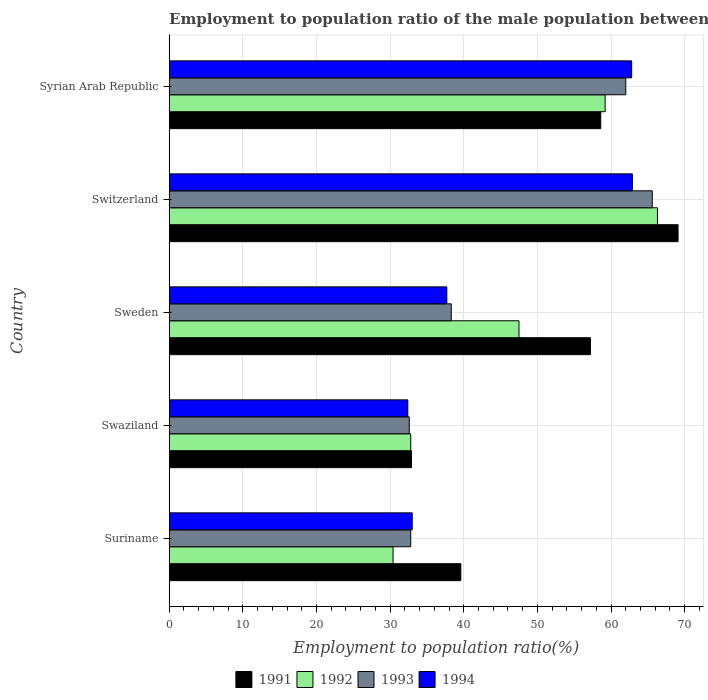How many different coloured bars are there?
Provide a short and direct response. 4. Are the number of bars on each tick of the Y-axis equal?
Make the answer very short. Yes. How many bars are there on the 1st tick from the top?
Your answer should be very brief. 4. How many bars are there on the 3rd tick from the bottom?
Ensure brevity in your answer.  4. What is the label of the 5th group of bars from the top?
Provide a succinct answer. Suriname. In how many cases, is the number of bars for a given country not equal to the number of legend labels?
Your response must be concise. 0. What is the employment to population ratio in 1991 in Suriname?
Your response must be concise. 39.6. Across all countries, what is the maximum employment to population ratio in 1993?
Offer a terse response. 65.6. Across all countries, what is the minimum employment to population ratio in 1991?
Offer a terse response. 32.9. In which country was the employment to population ratio in 1992 maximum?
Offer a terse response. Switzerland. In which country was the employment to population ratio in 1991 minimum?
Provide a succinct answer. Swaziland. What is the total employment to population ratio in 1993 in the graph?
Offer a very short reply. 231.3. What is the difference between the employment to population ratio in 1992 in Switzerland and that in Syrian Arab Republic?
Provide a short and direct response. 7.1. What is the average employment to population ratio in 1993 per country?
Make the answer very short. 46.26. What is the difference between the employment to population ratio in 1992 and employment to population ratio in 1994 in Syrian Arab Republic?
Ensure brevity in your answer.  -3.6. What is the ratio of the employment to population ratio in 1992 in Switzerland to that in Syrian Arab Republic?
Your response must be concise. 1.12. Is the difference between the employment to population ratio in 1992 in Swaziland and Syrian Arab Republic greater than the difference between the employment to population ratio in 1994 in Swaziland and Syrian Arab Republic?
Give a very brief answer. Yes. What is the difference between the highest and the second highest employment to population ratio in 1994?
Offer a very short reply. 0.1. What is the difference between the highest and the lowest employment to population ratio in 1991?
Offer a terse response. 36.2. In how many countries, is the employment to population ratio in 1992 greater than the average employment to population ratio in 1992 taken over all countries?
Your answer should be compact. 3. Is the sum of the employment to population ratio in 1992 in Suriname and Switzerland greater than the maximum employment to population ratio in 1994 across all countries?
Ensure brevity in your answer.  Yes. Is it the case that in every country, the sum of the employment to population ratio in 1992 and employment to population ratio in 1991 is greater than the sum of employment to population ratio in 1993 and employment to population ratio in 1994?
Provide a succinct answer. No. How many bars are there?
Make the answer very short. 20. Does the graph contain grids?
Make the answer very short. Yes. How are the legend labels stacked?
Offer a very short reply. Horizontal. What is the title of the graph?
Keep it short and to the point. Employment to population ratio of the male population between the ages 0 to 14. What is the label or title of the X-axis?
Give a very brief answer. Employment to population ratio(%). What is the label or title of the Y-axis?
Provide a short and direct response. Country. What is the Employment to population ratio(%) in 1991 in Suriname?
Offer a terse response. 39.6. What is the Employment to population ratio(%) of 1992 in Suriname?
Keep it short and to the point. 30.4. What is the Employment to population ratio(%) in 1993 in Suriname?
Provide a succinct answer. 32.8. What is the Employment to population ratio(%) of 1991 in Swaziland?
Your response must be concise. 32.9. What is the Employment to population ratio(%) of 1992 in Swaziland?
Give a very brief answer. 32.8. What is the Employment to population ratio(%) of 1993 in Swaziland?
Your answer should be compact. 32.6. What is the Employment to population ratio(%) in 1994 in Swaziland?
Make the answer very short. 32.4. What is the Employment to population ratio(%) of 1991 in Sweden?
Your answer should be very brief. 57.2. What is the Employment to population ratio(%) of 1992 in Sweden?
Offer a terse response. 47.5. What is the Employment to population ratio(%) of 1993 in Sweden?
Keep it short and to the point. 38.3. What is the Employment to population ratio(%) in 1994 in Sweden?
Offer a terse response. 37.7. What is the Employment to population ratio(%) in 1991 in Switzerland?
Ensure brevity in your answer.  69.1. What is the Employment to population ratio(%) of 1992 in Switzerland?
Your answer should be very brief. 66.3. What is the Employment to population ratio(%) of 1993 in Switzerland?
Offer a terse response. 65.6. What is the Employment to population ratio(%) of 1994 in Switzerland?
Make the answer very short. 62.9. What is the Employment to population ratio(%) in 1991 in Syrian Arab Republic?
Provide a succinct answer. 58.6. What is the Employment to population ratio(%) of 1992 in Syrian Arab Republic?
Provide a short and direct response. 59.2. What is the Employment to population ratio(%) of 1993 in Syrian Arab Republic?
Ensure brevity in your answer.  62. What is the Employment to population ratio(%) in 1994 in Syrian Arab Republic?
Keep it short and to the point. 62.8. Across all countries, what is the maximum Employment to population ratio(%) of 1991?
Give a very brief answer. 69.1. Across all countries, what is the maximum Employment to population ratio(%) of 1992?
Your answer should be very brief. 66.3. Across all countries, what is the maximum Employment to population ratio(%) of 1993?
Your response must be concise. 65.6. Across all countries, what is the maximum Employment to population ratio(%) of 1994?
Keep it short and to the point. 62.9. Across all countries, what is the minimum Employment to population ratio(%) of 1991?
Offer a very short reply. 32.9. Across all countries, what is the minimum Employment to population ratio(%) in 1992?
Your answer should be compact. 30.4. Across all countries, what is the minimum Employment to population ratio(%) in 1993?
Keep it short and to the point. 32.6. Across all countries, what is the minimum Employment to population ratio(%) of 1994?
Offer a terse response. 32.4. What is the total Employment to population ratio(%) of 1991 in the graph?
Ensure brevity in your answer.  257.4. What is the total Employment to population ratio(%) of 1992 in the graph?
Provide a short and direct response. 236.2. What is the total Employment to population ratio(%) of 1993 in the graph?
Give a very brief answer. 231.3. What is the total Employment to population ratio(%) in 1994 in the graph?
Ensure brevity in your answer.  228.8. What is the difference between the Employment to population ratio(%) of 1991 in Suriname and that in Swaziland?
Your answer should be very brief. 6.7. What is the difference between the Employment to population ratio(%) in 1994 in Suriname and that in Swaziland?
Offer a terse response. 0.6. What is the difference between the Employment to population ratio(%) in 1991 in Suriname and that in Sweden?
Ensure brevity in your answer.  -17.6. What is the difference between the Employment to population ratio(%) in 1992 in Suriname and that in Sweden?
Ensure brevity in your answer.  -17.1. What is the difference between the Employment to population ratio(%) of 1993 in Suriname and that in Sweden?
Make the answer very short. -5.5. What is the difference between the Employment to population ratio(%) in 1994 in Suriname and that in Sweden?
Provide a succinct answer. -4.7. What is the difference between the Employment to population ratio(%) of 1991 in Suriname and that in Switzerland?
Give a very brief answer. -29.5. What is the difference between the Employment to population ratio(%) of 1992 in Suriname and that in Switzerland?
Provide a succinct answer. -35.9. What is the difference between the Employment to population ratio(%) in 1993 in Suriname and that in Switzerland?
Make the answer very short. -32.8. What is the difference between the Employment to population ratio(%) in 1994 in Suriname and that in Switzerland?
Provide a short and direct response. -29.9. What is the difference between the Employment to population ratio(%) of 1992 in Suriname and that in Syrian Arab Republic?
Your answer should be compact. -28.8. What is the difference between the Employment to population ratio(%) in 1993 in Suriname and that in Syrian Arab Republic?
Keep it short and to the point. -29.2. What is the difference between the Employment to population ratio(%) of 1994 in Suriname and that in Syrian Arab Republic?
Your answer should be compact. -29.8. What is the difference between the Employment to population ratio(%) in 1991 in Swaziland and that in Sweden?
Make the answer very short. -24.3. What is the difference between the Employment to population ratio(%) of 1992 in Swaziland and that in Sweden?
Give a very brief answer. -14.7. What is the difference between the Employment to population ratio(%) in 1994 in Swaziland and that in Sweden?
Your answer should be compact. -5.3. What is the difference between the Employment to population ratio(%) of 1991 in Swaziland and that in Switzerland?
Provide a succinct answer. -36.2. What is the difference between the Employment to population ratio(%) in 1992 in Swaziland and that in Switzerland?
Offer a terse response. -33.5. What is the difference between the Employment to population ratio(%) of 1993 in Swaziland and that in Switzerland?
Give a very brief answer. -33. What is the difference between the Employment to population ratio(%) in 1994 in Swaziland and that in Switzerland?
Make the answer very short. -30.5. What is the difference between the Employment to population ratio(%) in 1991 in Swaziland and that in Syrian Arab Republic?
Offer a very short reply. -25.7. What is the difference between the Employment to population ratio(%) of 1992 in Swaziland and that in Syrian Arab Republic?
Ensure brevity in your answer.  -26.4. What is the difference between the Employment to population ratio(%) in 1993 in Swaziland and that in Syrian Arab Republic?
Ensure brevity in your answer.  -29.4. What is the difference between the Employment to population ratio(%) in 1994 in Swaziland and that in Syrian Arab Republic?
Offer a terse response. -30.4. What is the difference between the Employment to population ratio(%) of 1991 in Sweden and that in Switzerland?
Ensure brevity in your answer.  -11.9. What is the difference between the Employment to population ratio(%) in 1992 in Sweden and that in Switzerland?
Make the answer very short. -18.8. What is the difference between the Employment to population ratio(%) in 1993 in Sweden and that in Switzerland?
Your response must be concise. -27.3. What is the difference between the Employment to population ratio(%) in 1994 in Sweden and that in Switzerland?
Offer a very short reply. -25.2. What is the difference between the Employment to population ratio(%) of 1991 in Sweden and that in Syrian Arab Republic?
Make the answer very short. -1.4. What is the difference between the Employment to population ratio(%) of 1992 in Sweden and that in Syrian Arab Republic?
Your answer should be very brief. -11.7. What is the difference between the Employment to population ratio(%) in 1993 in Sweden and that in Syrian Arab Republic?
Offer a terse response. -23.7. What is the difference between the Employment to population ratio(%) of 1994 in Sweden and that in Syrian Arab Republic?
Provide a succinct answer. -25.1. What is the difference between the Employment to population ratio(%) of 1994 in Switzerland and that in Syrian Arab Republic?
Keep it short and to the point. 0.1. What is the difference between the Employment to population ratio(%) in 1991 in Suriname and the Employment to population ratio(%) in 1992 in Swaziland?
Provide a succinct answer. 6.8. What is the difference between the Employment to population ratio(%) in 1991 in Suriname and the Employment to population ratio(%) in 1993 in Swaziland?
Provide a succinct answer. 7. What is the difference between the Employment to population ratio(%) in 1991 in Suriname and the Employment to population ratio(%) in 1992 in Sweden?
Offer a terse response. -7.9. What is the difference between the Employment to population ratio(%) in 1993 in Suriname and the Employment to population ratio(%) in 1994 in Sweden?
Offer a very short reply. -4.9. What is the difference between the Employment to population ratio(%) in 1991 in Suriname and the Employment to population ratio(%) in 1992 in Switzerland?
Ensure brevity in your answer.  -26.7. What is the difference between the Employment to population ratio(%) of 1991 in Suriname and the Employment to population ratio(%) of 1994 in Switzerland?
Your answer should be compact. -23.3. What is the difference between the Employment to population ratio(%) in 1992 in Suriname and the Employment to population ratio(%) in 1993 in Switzerland?
Your answer should be compact. -35.2. What is the difference between the Employment to population ratio(%) of 1992 in Suriname and the Employment to population ratio(%) of 1994 in Switzerland?
Your answer should be very brief. -32.5. What is the difference between the Employment to population ratio(%) of 1993 in Suriname and the Employment to population ratio(%) of 1994 in Switzerland?
Your answer should be very brief. -30.1. What is the difference between the Employment to population ratio(%) in 1991 in Suriname and the Employment to population ratio(%) in 1992 in Syrian Arab Republic?
Your answer should be compact. -19.6. What is the difference between the Employment to population ratio(%) in 1991 in Suriname and the Employment to population ratio(%) in 1993 in Syrian Arab Republic?
Give a very brief answer. -22.4. What is the difference between the Employment to population ratio(%) of 1991 in Suriname and the Employment to population ratio(%) of 1994 in Syrian Arab Republic?
Your response must be concise. -23.2. What is the difference between the Employment to population ratio(%) of 1992 in Suriname and the Employment to population ratio(%) of 1993 in Syrian Arab Republic?
Make the answer very short. -31.6. What is the difference between the Employment to population ratio(%) of 1992 in Suriname and the Employment to population ratio(%) of 1994 in Syrian Arab Republic?
Provide a short and direct response. -32.4. What is the difference between the Employment to population ratio(%) of 1991 in Swaziland and the Employment to population ratio(%) of 1992 in Sweden?
Your answer should be compact. -14.6. What is the difference between the Employment to population ratio(%) in 1991 in Swaziland and the Employment to population ratio(%) in 1994 in Sweden?
Your response must be concise. -4.8. What is the difference between the Employment to population ratio(%) in 1992 in Swaziland and the Employment to population ratio(%) in 1993 in Sweden?
Your answer should be very brief. -5.5. What is the difference between the Employment to population ratio(%) in 1992 in Swaziland and the Employment to population ratio(%) in 1994 in Sweden?
Your answer should be compact. -4.9. What is the difference between the Employment to population ratio(%) in 1993 in Swaziland and the Employment to population ratio(%) in 1994 in Sweden?
Your answer should be compact. -5.1. What is the difference between the Employment to population ratio(%) of 1991 in Swaziland and the Employment to population ratio(%) of 1992 in Switzerland?
Give a very brief answer. -33.4. What is the difference between the Employment to population ratio(%) in 1991 in Swaziland and the Employment to population ratio(%) in 1993 in Switzerland?
Keep it short and to the point. -32.7. What is the difference between the Employment to population ratio(%) in 1991 in Swaziland and the Employment to population ratio(%) in 1994 in Switzerland?
Your response must be concise. -30. What is the difference between the Employment to population ratio(%) in 1992 in Swaziland and the Employment to population ratio(%) in 1993 in Switzerland?
Offer a terse response. -32.8. What is the difference between the Employment to population ratio(%) in 1992 in Swaziland and the Employment to population ratio(%) in 1994 in Switzerland?
Offer a very short reply. -30.1. What is the difference between the Employment to population ratio(%) in 1993 in Swaziland and the Employment to population ratio(%) in 1994 in Switzerland?
Ensure brevity in your answer.  -30.3. What is the difference between the Employment to population ratio(%) in 1991 in Swaziland and the Employment to population ratio(%) in 1992 in Syrian Arab Republic?
Ensure brevity in your answer.  -26.3. What is the difference between the Employment to population ratio(%) of 1991 in Swaziland and the Employment to population ratio(%) of 1993 in Syrian Arab Republic?
Provide a succinct answer. -29.1. What is the difference between the Employment to population ratio(%) of 1991 in Swaziland and the Employment to population ratio(%) of 1994 in Syrian Arab Republic?
Ensure brevity in your answer.  -29.9. What is the difference between the Employment to population ratio(%) in 1992 in Swaziland and the Employment to population ratio(%) in 1993 in Syrian Arab Republic?
Keep it short and to the point. -29.2. What is the difference between the Employment to population ratio(%) of 1992 in Swaziland and the Employment to population ratio(%) of 1994 in Syrian Arab Republic?
Your answer should be compact. -30. What is the difference between the Employment to population ratio(%) in 1993 in Swaziland and the Employment to population ratio(%) in 1994 in Syrian Arab Republic?
Give a very brief answer. -30.2. What is the difference between the Employment to population ratio(%) of 1991 in Sweden and the Employment to population ratio(%) of 1992 in Switzerland?
Ensure brevity in your answer.  -9.1. What is the difference between the Employment to population ratio(%) in 1992 in Sweden and the Employment to population ratio(%) in 1993 in Switzerland?
Your answer should be very brief. -18.1. What is the difference between the Employment to population ratio(%) of 1992 in Sweden and the Employment to population ratio(%) of 1994 in Switzerland?
Offer a very short reply. -15.4. What is the difference between the Employment to population ratio(%) of 1993 in Sweden and the Employment to population ratio(%) of 1994 in Switzerland?
Your answer should be very brief. -24.6. What is the difference between the Employment to population ratio(%) of 1991 in Sweden and the Employment to population ratio(%) of 1992 in Syrian Arab Republic?
Your answer should be compact. -2. What is the difference between the Employment to population ratio(%) of 1991 in Sweden and the Employment to population ratio(%) of 1993 in Syrian Arab Republic?
Provide a succinct answer. -4.8. What is the difference between the Employment to population ratio(%) of 1992 in Sweden and the Employment to population ratio(%) of 1994 in Syrian Arab Republic?
Offer a very short reply. -15.3. What is the difference between the Employment to population ratio(%) of 1993 in Sweden and the Employment to population ratio(%) of 1994 in Syrian Arab Republic?
Provide a succinct answer. -24.5. What is the difference between the Employment to population ratio(%) in 1991 in Switzerland and the Employment to population ratio(%) in 1993 in Syrian Arab Republic?
Keep it short and to the point. 7.1. What is the difference between the Employment to population ratio(%) of 1992 in Switzerland and the Employment to population ratio(%) of 1994 in Syrian Arab Republic?
Provide a short and direct response. 3.5. What is the average Employment to population ratio(%) in 1991 per country?
Offer a terse response. 51.48. What is the average Employment to population ratio(%) in 1992 per country?
Offer a terse response. 47.24. What is the average Employment to population ratio(%) in 1993 per country?
Offer a very short reply. 46.26. What is the average Employment to population ratio(%) in 1994 per country?
Offer a terse response. 45.76. What is the difference between the Employment to population ratio(%) in 1991 and Employment to population ratio(%) in 1992 in Suriname?
Give a very brief answer. 9.2. What is the difference between the Employment to population ratio(%) of 1991 and Employment to population ratio(%) of 1993 in Suriname?
Make the answer very short. 6.8. What is the difference between the Employment to population ratio(%) in 1991 and Employment to population ratio(%) in 1994 in Suriname?
Your answer should be very brief. 6.6. What is the difference between the Employment to population ratio(%) in 1991 and Employment to population ratio(%) in 1993 in Swaziland?
Provide a succinct answer. 0.3. What is the difference between the Employment to population ratio(%) of 1991 and Employment to population ratio(%) of 1994 in Swaziland?
Make the answer very short. 0.5. What is the difference between the Employment to population ratio(%) in 1992 and Employment to population ratio(%) in 1994 in Swaziland?
Ensure brevity in your answer.  0.4. What is the difference between the Employment to population ratio(%) of 1991 and Employment to population ratio(%) of 1992 in Sweden?
Your answer should be very brief. 9.7. What is the difference between the Employment to population ratio(%) of 1993 and Employment to population ratio(%) of 1994 in Sweden?
Provide a short and direct response. 0.6. What is the difference between the Employment to population ratio(%) of 1991 and Employment to population ratio(%) of 1992 in Switzerland?
Give a very brief answer. 2.8. What is the difference between the Employment to population ratio(%) in 1991 and Employment to population ratio(%) in 1994 in Switzerland?
Your answer should be compact. 6.2. What is the difference between the Employment to population ratio(%) in 1992 and Employment to population ratio(%) in 1993 in Switzerland?
Ensure brevity in your answer.  0.7. What is the difference between the Employment to population ratio(%) of 1992 and Employment to population ratio(%) of 1994 in Switzerland?
Provide a short and direct response. 3.4. What is the difference between the Employment to population ratio(%) of 1993 and Employment to population ratio(%) of 1994 in Syrian Arab Republic?
Your answer should be very brief. -0.8. What is the ratio of the Employment to population ratio(%) of 1991 in Suriname to that in Swaziland?
Make the answer very short. 1.2. What is the ratio of the Employment to population ratio(%) in 1992 in Suriname to that in Swaziland?
Offer a terse response. 0.93. What is the ratio of the Employment to population ratio(%) of 1994 in Suriname to that in Swaziland?
Your answer should be compact. 1.02. What is the ratio of the Employment to population ratio(%) in 1991 in Suriname to that in Sweden?
Make the answer very short. 0.69. What is the ratio of the Employment to population ratio(%) of 1992 in Suriname to that in Sweden?
Your response must be concise. 0.64. What is the ratio of the Employment to population ratio(%) of 1993 in Suriname to that in Sweden?
Ensure brevity in your answer.  0.86. What is the ratio of the Employment to population ratio(%) in 1994 in Suriname to that in Sweden?
Offer a terse response. 0.88. What is the ratio of the Employment to population ratio(%) of 1991 in Suriname to that in Switzerland?
Provide a short and direct response. 0.57. What is the ratio of the Employment to population ratio(%) in 1992 in Suriname to that in Switzerland?
Provide a short and direct response. 0.46. What is the ratio of the Employment to population ratio(%) in 1993 in Suriname to that in Switzerland?
Provide a succinct answer. 0.5. What is the ratio of the Employment to population ratio(%) of 1994 in Suriname to that in Switzerland?
Give a very brief answer. 0.52. What is the ratio of the Employment to population ratio(%) in 1991 in Suriname to that in Syrian Arab Republic?
Keep it short and to the point. 0.68. What is the ratio of the Employment to population ratio(%) of 1992 in Suriname to that in Syrian Arab Republic?
Offer a very short reply. 0.51. What is the ratio of the Employment to population ratio(%) in 1993 in Suriname to that in Syrian Arab Republic?
Offer a very short reply. 0.53. What is the ratio of the Employment to population ratio(%) in 1994 in Suriname to that in Syrian Arab Republic?
Offer a terse response. 0.53. What is the ratio of the Employment to population ratio(%) in 1991 in Swaziland to that in Sweden?
Keep it short and to the point. 0.58. What is the ratio of the Employment to population ratio(%) in 1992 in Swaziland to that in Sweden?
Offer a very short reply. 0.69. What is the ratio of the Employment to population ratio(%) of 1993 in Swaziland to that in Sweden?
Give a very brief answer. 0.85. What is the ratio of the Employment to population ratio(%) of 1994 in Swaziland to that in Sweden?
Keep it short and to the point. 0.86. What is the ratio of the Employment to population ratio(%) in 1991 in Swaziland to that in Switzerland?
Your response must be concise. 0.48. What is the ratio of the Employment to population ratio(%) in 1992 in Swaziland to that in Switzerland?
Make the answer very short. 0.49. What is the ratio of the Employment to population ratio(%) in 1993 in Swaziland to that in Switzerland?
Give a very brief answer. 0.5. What is the ratio of the Employment to population ratio(%) in 1994 in Swaziland to that in Switzerland?
Ensure brevity in your answer.  0.52. What is the ratio of the Employment to population ratio(%) in 1991 in Swaziland to that in Syrian Arab Republic?
Offer a terse response. 0.56. What is the ratio of the Employment to population ratio(%) of 1992 in Swaziland to that in Syrian Arab Republic?
Provide a short and direct response. 0.55. What is the ratio of the Employment to population ratio(%) of 1993 in Swaziland to that in Syrian Arab Republic?
Your answer should be compact. 0.53. What is the ratio of the Employment to population ratio(%) in 1994 in Swaziland to that in Syrian Arab Republic?
Your answer should be compact. 0.52. What is the ratio of the Employment to population ratio(%) in 1991 in Sweden to that in Switzerland?
Offer a terse response. 0.83. What is the ratio of the Employment to population ratio(%) of 1992 in Sweden to that in Switzerland?
Ensure brevity in your answer.  0.72. What is the ratio of the Employment to population ratio(%) of 1993 in Sweden to that in Switzerland?
Give a very brief answer. 0.58. What is the ratio of the Employment to population ratio(%) in 1994 in Sweden to that in Switzerland?
Provide a succinct answer. 0.6. What is the ratio of the Employment to population ratio(%) of 1991 in Sweden to that in Syrian Arab Republic?
Offer a very short reply. 0.98. What is the ratio of the Employment to population ratio(%) of 1992 in Sweden to that in Syrian Arab Republic?
Offer a terse response. 0.8. What is the ratio of the Employment to population ratio(%) of 1993 in Sweden to that in Syrian Arab Republic?
Give a very brief answer. 0.62. What is the ratio of the Employment to population ratio(%) in 1994 in Sweden to that in Syrian Arab Republic?
Ensure brevity in your answer.  0.6. What is the ratio of the Employment to population ratio(%) in 1991 in Switzerland to that in Syrian Arab Republic?
Your response must be concise. 1.18. What is the ratio of the Employment to population ratio(%) of 1992 in Switzerland to that in Syrian Arab Republic?
Offer a terse response. 1.12. What is the ratio of the Employment to population ratio(%) in 1993 in Switzerland to that in Syrian Arab Republic?
Keep it short and to the point. 1.06. What is the difference between the highest and the second highest Employment to population ratio(%) in 1993?
Your response must be concise. 3.6. What is the difference between the highest and the second highest Employment to population ratio(%) in 1994?
Your answer should be compact. 0.1. What is the difference between the highest and the lowest Employment to population ratio(%) of 1991?
Your response must be concise. 36.2. What is the difference between the highest and the lowest Employment to population ratio(%) in 1992?
Keep it short and to the point. 35.9. What is the difference between the highest and the lowest Employment to population ratio(%) in 1994?
Your answer should be very brief. 30.5. 